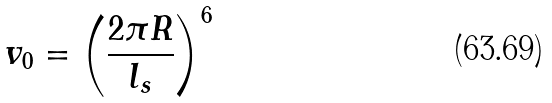<formula> <loc_0><loc_0><loc_500><loc_500>v _ { 0 } = \left ( \frac { 2 \pi R } { l _ { s } } \right ) ^ { 6 }</formula> 